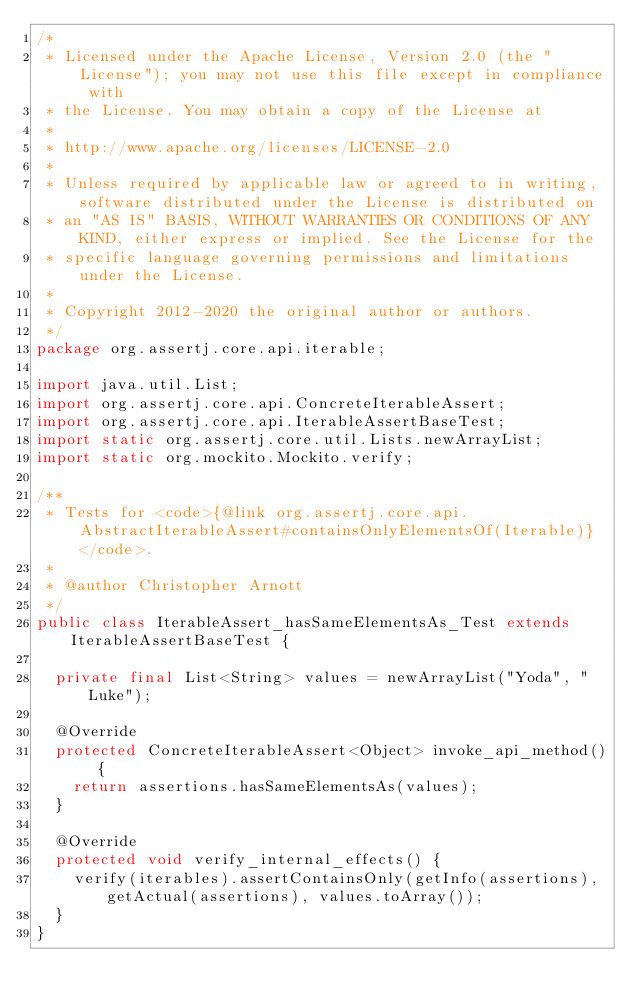<code> <loc_0><loc_0><loc_500><loc_500><_Java_>/*
 * Licensed under the Apache License, Version 2.0 (the "License"); you may not use this file except in compliance with
 * the License. You may obtain a copy of the License at
 *
 * http://www.apache.org/licenses/LICENSE-2.0
 *
 * Unless required by applicable law or agreed to in writing, software distributed under the License is distributed on
 * an "AS IS" BASIS, WITHOUT WARRANTIES OR CONDITIONS OF ANY KIND, either express or implied. See the License for the
 * specific language governing permissions and limitations under the License.
 *
 * Copyright 2012-2020 the original author or authors.
 */
package org.assertj.core.api.iterable;

import java.util.List;
import org.assertj.core.api.ConcreteIterableAssert;
import org.assertj.core.api.IterableAssertBaseTest;
import static org.assertj.core.util.Lists.newArrayList;
import static org.mockito.Mockito.verify;

/**
 * Tests for <code>{@link org.assertj.core.api.AbstractIterableAssert#containsOnlyElementsOf(Iterable)} </code>.
 * 
 * @author Christopher Arnott
 */
public class IterableAssert_hasSameElementsAs_Test extends IterableAssertBaseTest {

  private final List<String> values = newArrayList("Yoda", "Luke");

  @Override
  protected ConcreteIterableAssert<Object> invoke_api_method() {
    return assertions.hasSameElementsAs(values);
  }

  @Override
  protected void verify_internal_effects() {
    verify(iterables).assertContainsOnly(getInfo(assertions), getActual(assertions), values.toArray());
  }
}
</code> 